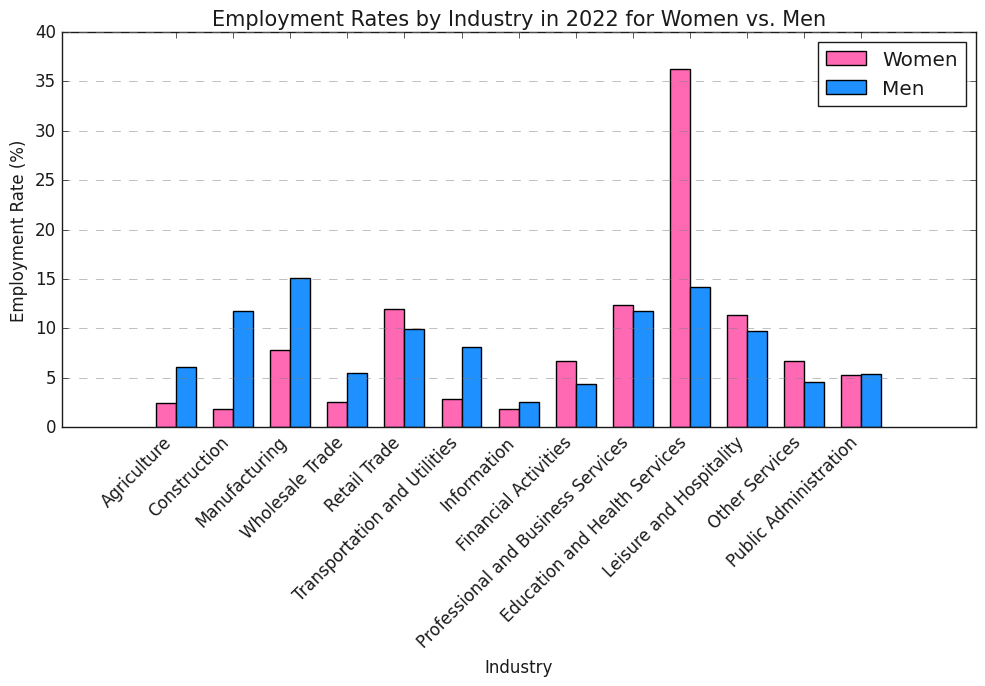Which industry has the highest employment rate for women in the most recent year? To determine this, look at the tallest bar among the pink bars. The bar corresponding to "Education and Health Services" is the tallest.
Answer: Education and Health Services Is the employment rate for women in retail trade higher or lower than men in the same industry for the most recent year? Compare the height of the pink bar to the blue bar for the "Retail Trade" industry. The pink bar (women) is slightly higher than the blue bar (men).
Answer: Higher What is the difference in employment rates between men and women in the construction industry in the most recent year? Look at the bars for the "Construction" industry and subtract the employment rate for women from the employment rate for men (11.8% - 1.8%).
Answer: 10.0% Which industry shows a more equal employment rate between women and men? Compare the height of the bars for each industry and see which pair of bars have the smallest difference in height. The "Public Administration" industry has nearly equal bars.
Answer: Public Administration What is the sum of employment rates for women in the Professional and Business Services and Financial Activities industries? Add the employment rates for women in the "Professional and Business Services" (12.4%) and "Financial Activities" (6.7%) industries.
Answer: 19.1% In which industry is the gap between employment rates for women and men the largest? To find this, compare the difference in heights of the bars for each industry. The largest gap is in the "Construction" industry.
Answer: Construction Does Financial Activities have a higher employment rate for women than Manufacturing has for men? Compare the height of the pink bar for "Financial Activities" (6.7%) against the blue bar for "Manufacturing" (15.1%).
Answer: No Which gender has higher employment in the Information industry? Compare the height of the bars for the "Information" industry. The blue bar (men) is slightly higher.
Answer: Men What is the average employment rate for men across all industries in the most recent year? Sum up the employment rates for men across all industries (6.1 + 11.8 + 15.1 + 5.5 + 9.9 + 8.1 + 2.5 + 4.4 + 11.8 + 14.2 + 9.7 + 4.6 + 5.4) which equals 110.7, then divide by the number of industries (13).
Answer: 8.52 